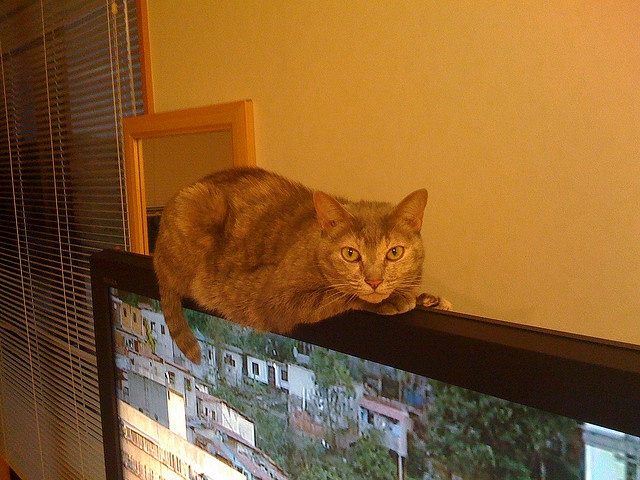Describe the objects in this image and their specific colors. I can see tv in black, gray, darkgray, and maroon tones and cat in black, brown, and maroon tones in this image. 